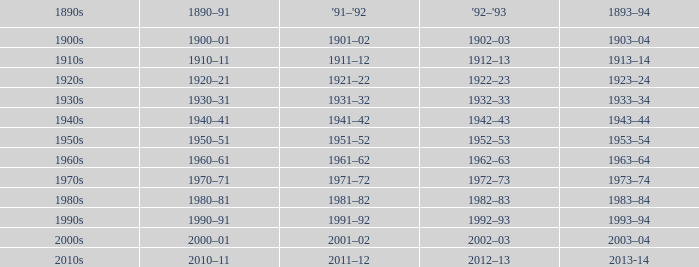What years from 1893-94 that is from the 1890s to the 1990s? 1993–94. 